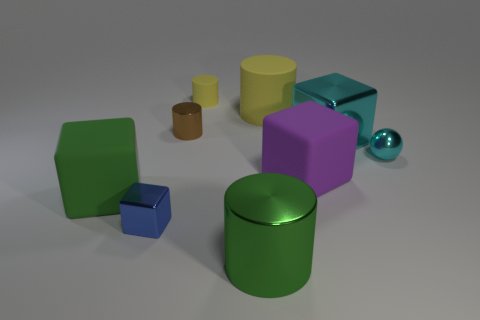Subtract all large yellow rubber cylinders. How many cylinders are left? 3 Subtract all purple cylinders. Subtract all purple blocks. How many cylinders are left? 4 Subtract all cubes. How many objects are left? 5 Subtract all tiny yellow balls. Subtract all big cylinders. How many objects are left? 7 Add 6 big purple things. How many big purple things are left? 7 Add 6 tiny yellow metallic things. How many tiny yellow metallic things exist? 6 Subtract 0 purple cylinders. How many objects are left? 9 